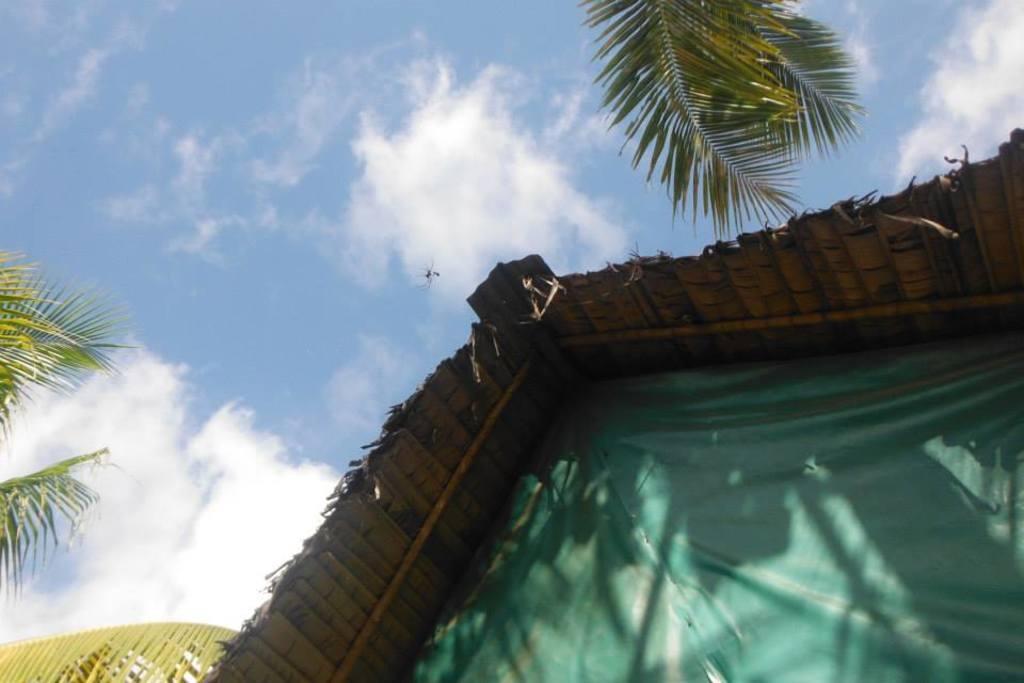In one or two sentences, can you explain what this image depicts? In this image, in the foreground I can see a tent house, and in the background I can see the sky 